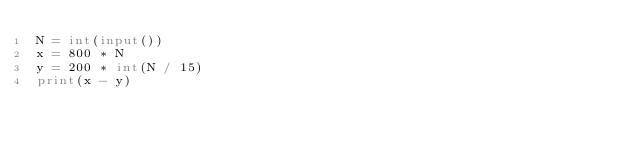<code> <loc_0><loc_0><loc_500><loc_500><_Python_>N = int(input())
x = 800 * N
y = 200 * int(N / 15)
print(x - y)</code> 